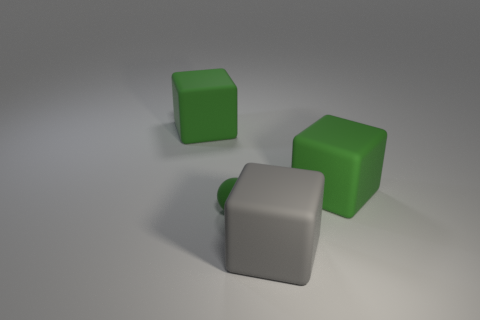Add 4 big things. How many objects exist? 8 Subtract all spheres. How many objects are left? 3 Subtract all small green balls. Subtract all matte blocks. How many objects are left? 0 Add 2 green objects. How many green objects are left? 5 Add 3 big green matte objects. How many big green matte objects exist? 5 Subtract 0 purple cubes. How many objects are left? 4 